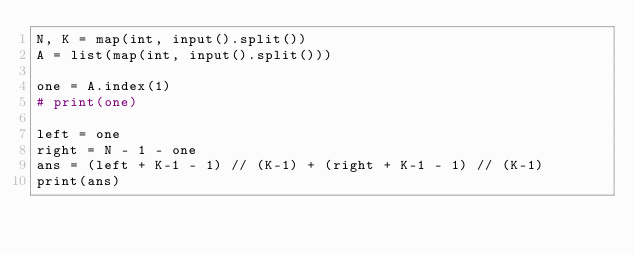Convert code to text. <code><loc_0><loc_0><loc_500><loc_500><_Python_>N, K = map(int, input().split())
A = list(map(int, input().split()))

one = A.index(1)
# print(one)

left = one
right = N - 1 - one
ans = (left + K-1 - 1) // (K-1) + (right + K-1 - 1) // (K-1)
print(ans)</code> 